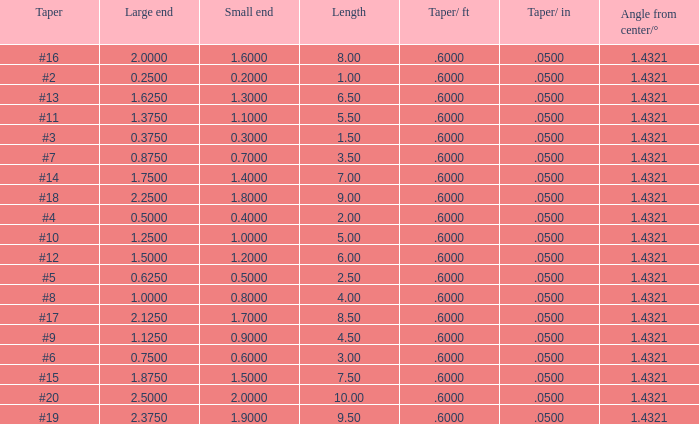Which Taper/in that has a Small end larger than 0.7000000000000001, and a Taper of #19, and a Large end larger than 2.375? None. 